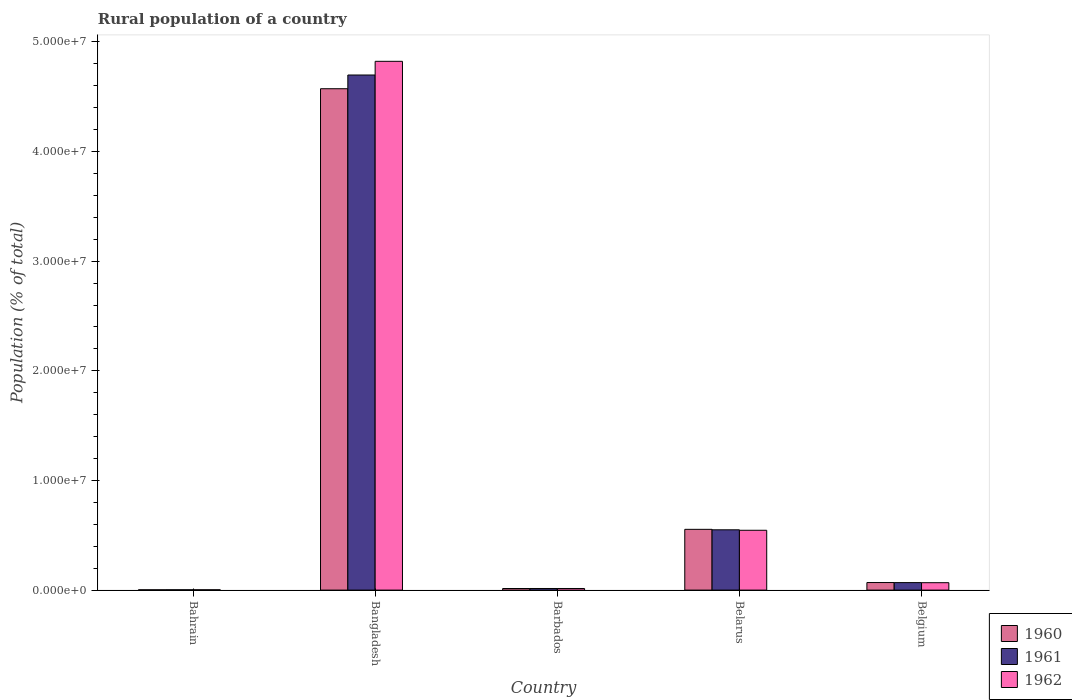How many different coloured bars are there?
Give a very brief answer. 3. How many bars are there on the 5th tick from the left?
Offer a very short reply. 3. How many bars are there on the 4th tick from the right?
Offer a terse response. 3. What is the rural population in 1961 in Belgium?
Offer a terse response. 6.84e+05. Across all countries, what is the maximum rural population in 1960?
Ensure brevity in your answer.  4.57e+07. Across all countries, what is the minimum rural population in 1962?
Keep it short and to the point. 3.05e+04. In which country was the rural population in 1962 maximum?
Your answer should be very brief. Bangladesh. In which country was the rural population in 1962 minimum?
Provide a short and direct response. Bahrain. What is the total rural population in 1962 in the graph?
Your response must be concise. 5.45e+07. What is the difference between the rural population in 1962 in Bahrain and that in Belarus?
Keep it short and to the point. -5.43e+06. What is the difference between the rural population in 1961 in Belarus and the rural population in 1960 in Barbados?
Offer a very short reply. 5.35e+06. What is the average rural population in 1960 per country?
Make the answer very short. 1.04e+07. What is the difference between the rural population of/in 1960 and rural population of/in 1961 in Bangladesh?
Make the answer very short. -1.25e+06. In how many countries, is the rural population in 1960 greater than 4000000 %?
Ensure brevity in your answer.  2. What is the ratio of the rural population in 1960 in Barbados to that in Belarus?
Offer a terse response. 0.03. What is the difference between the highest and the second highest rural population in 1961?
Your response must be concise. 4.63e+07. What is the difference between the highest and the lowest rural population in 1961?
Provide a succinct answer. 4.69e+07. What does the 1st bar from the left in Belarus represents?
Provide a succinct answer. 1960. What does the 3rd bar from the right in Bangladesh represents?
Your response must be concise. 1960. Are all the bars in the graph horizontal?
Keep it short and to the point. No. What is the difference between two consecutive major ticks on the Y-axis?
Offer a very short reply. 1.00e+07. Are the values on the major ticks of Y-axis written in scientific E-notation?
Provide a short and direct response. Yes. Does the graph contain any zero values?
Offer a very short reply. No. Does the graph contain grids?
Offer a terse response. No. What is the title of the graph?
Keep it short and to the point. Rural population of a country. What is the label or title of the Y-axis?
Ensure brevity in your answer.  Population (% of total). What is the Population (% of total) of 1960 in Bahrain?
Offer a terse response. 2.87e+04. What is the Population (% of total) of 1961 in Bahrain?
Your response must be concise. 2.97e+04. What is the Population (% of total) of 1962 in Bahrain?
Offer a very short reply. 3.05e+04. What is the Population (% of total) in 1960 in Bangladesh?
Offer a very short reply. 4.57e+07. What is the Population (% of total) in 1961 in Bangladesh?
Make the answer very short. 4.70e+07. What is the Population (% of total) of 1962 in Bangladesh?
Your answer should be compact. 4.82e+07. What is the Population (% of total) of 1960 in Barbados?
Your answer should be very brief. 1.46e+05. What is the Population (% of total) in 1961 in Barbados?
Provide a short and direct response. 1.46e+05. What is the Population (% of total) in 1962 in Barbados?
Give a very brief answer. 1.47e+05. What is the Population (% of total) in 1960 in Belarus?
Offer a very short reply. 5.54e+06. What is the Population (% of total) in 1961 in Belarus?
Keep it short and to the point. 5.50e+06. What is the Population (% of total) in 1962 in Belarus?
Your answer should be compact. 5.46e+06. What is the Population (% of total) in 1960 in Belgium?
Offer a very short reply. 6.90e+05. What is the Population (% of total) of 1961 in Belgium?
Offer a very short reply. 6.84e+05. What is the Population (% of total) of 1962 in Belgium?
Ensure brevity in your answer.  6.75e+05. Across all countries, what is the maximum Population (% of total) in 1960?
Provide a short and direct response. 4.57e+07. Across all countries, what is the maximum Population (% of total) of 1961?
Provide a succinct answer. 4.70e+07. Across all countries, what is the maximum Population (% of total) of 1962?
Keep it short and to the point. 4.82e+07. Across all countries, what is the minimum Population (% of total) in 1960?
Make the answer very short. 2.87e+04. Across all countries, what is the minimum Population (% of total) of 1961?
Your answer should be compact. 2.97e+04. Across all countries, what is the minimum Population (% of total) in 1962?
Provide a short and direct response. 3.05e+04. What is the total Population (% of total) of 1960 in the graph?
Give a very brief answer. 5.21e+07. What is the total Population (% of total) in 1961 in the graph?
Make the answer very short. 5.33e+07. What is the total Population (% of total) of 1962 in the graph?
Provide a succinct answer. 5.45e+07. What is the difference between the Population (% of total) in 1960 in Bahrain and that in Bangladesh?
Your answer should be compact. -4.57e+07. What is the difference between the Population (% of total) of 1961 in Bahrain and that in Bangladesh?
Ensure brevity in your answer.  -4.69e+07. What is the difference between the Population (% of total) in 1962 in Bahrain and that in Bangladesh?
Keep it short and to the point. -4.82e+07. What is the difference between the Population (% of total) of 1960 in Bahrain and that in Barbados?
Offer a very short reply. -1.17e+05. What is the difference between the Population (% of total) of 1961 in Bahrain and that in Barbados?
Provide a succinct answer. -1.17e+05. What is the difference between the Population (% of total) of 1962 in Bahrain and that in Barbados?
Provide a succinct answer. -1.16e+05. What is the difference between the Population (% of total) of 1960 in Bahrain and that in Belarus?
Your response must be concise. -5.51e+06. What is the difference between the Population (% of total) in 1961 in Bahrain and that in Belarus?
Provide a short and direct response. -5.47e+06. What is the difference between the Population (% of total) in 1962 in Bahrain and that in Belarus?
Your answer should be compact. -5.43e+06. What is the difference between the Population (% of total) of 1960 in Bahrain and that in Belgium?
Offer a terse response. -6.61e+05. What is the difference between the Population (% of total) in 1961 in Bahrain and that in Belgium?
Give a very brief answer. -6.54e+05. What is the difference between the Population (% of total) in 1962 in Bahrain and that in Belgium?
Ensure brevity in your answer.  -6.44e+05. What is the difference between the Population (% of total) of 1960 in Bangladesh and that in Barbados?
Keep it short and to the point. 4.56e+07. What is the difference between the Population (% of total) in 1961 in Bangladesh and that in Barbados?
Your answer should be compact. 4.68e+07. What is the difference between the Population (% of total) of 1962 in Bangladesh and that in Barbados?
Your response must be concise. 4.81e+07. What is the difference between the Population (% of total) of 1960 in Bangladesh and that in Belarus?
Offer a very short reply. 4.02e+07. What is the difference between the Population (% of total) of 1961 in Bangladesh and that in Belarus?
Give a very brief answer. 4.15e+07. What is the difference between the Population (% of total) of 1962 in Bangladesh and that in Belarus?
Make the answer very short. 4.28e+07. What is the difference between the Population (% of total) of 1960 in Bangladesh and that in Belgium?
Keep it short and to the point. 4.50e+07. What is the difference between the Population (% of total) of 1961 in Bangladesh and that in Belgium?
Keep it short and to the point. 4.63e+07. What is the difference between the Population (% of total) in 1962 in Bangladesh and that in Belgium?
Provide a succinct answer. 4.75e+07. What is the difference between the Population (% of total) of 1960 in Barbados and that in Belarus?
Give a very brief answer. -5.40e+06. What is the difference between the Population (% of total) of 1961 in Barbados and that in Belarus?
Your answer should be compact. -5.35e+06. What is the difference between the Population (% of total) in 1962 in Barbados and that in Belarus?
Your answer should be very brief. -5.31e+06. What is the difference between the Population (% of total) of 1960 in Barbados and that in Belgium?
Give a very brief answer. -5.44e+05. What is the difference between the Population (% of total) in 1961 in Barbados and that in Belgium?
Provide a succinct answer. -5.38e+05. What is the difference between the Population (% of total) of 1962 in Barbados and that in Belgium?
Provide a succinct answer. -5.28e+05. What is the difference between the Population (% of total) of 1960 in Belarus and that in Belgium?
Make the answer very short. 4.85e+06. What is the difference between the Population (% of total) of 1961 in Belarus and that in Belgium?
Keep it short and to the point. 4.81e+06. What is the difference between the Population (% of total) of 1962 in Belarus and that in Belgium?
Provide a succinct answer. 4.78e+06. What is the difference between the Population (% of total) in 1960 in Bahrain and the Population (% of total) in 1961 in Bangladesh?
Your response must be concise. -4.69e+07. What is the difference between the Population (% of total) in 1960 in Bahrain and the Population (% of total) in 1962 in Bangladesh?
Provide a succinct answer. -4.82e+07. What is the difference between the Population (% of total) of 1961 in Bahrain and the Population (% of total) of 1962 in Bangladesh?
Make the answer very short. -4.82e+07. What is the difference between the Population (% of total) of 1960 in Bahrain and the Population (% of total) of 1961 in Barbados?
Provide a succinct answer. -1.18e+05. What is the difference between the Population (% of total) of 1960 in Bahrain and the Population (% of total) of 1962 in Barbados?
Ensure brevity in your answer.  -1.18e+05. What is the difference between the Population (% of total) in 1961 in Bahrain and the Population (% of total) in 1962 in Barbados?
Give a very brief answer. -1.17e+05. What is the difference between the Population (% of total) of 1960 in Bahrain and the Population (% of total) of 1961 in Belarus?
Provide a short and direct response. -5.47e+06. What is the difference between the Population (% of total) of 1960 in Bahrain and the Population (% of total) of 1962 in Belarus?
Provide a succinct answer. -5.43e+06. What is the difference between the Population (% of total) of 1961 in Bahrain and the Population (% of total) of 1962 in Belarus?
Ensure brevity in your answer.  -5.43e+06. What is the difference between the Population (% of total) of 1960 in Bahrain and the Population (% of total) of 1961 in Belgium?
Provide a short and direct response. -6.55e+05. What is the difference between the Population (% of total) of 1960 in Bahrain and the Population (% of total) of 1962 in Belgium?
Offer a terse response. -6.46e+05. What is the difference between the Population (% of total) of 1961 in Bahrain and the Population (% of total) of 1962 in Belgium?
Your answer should be very brief. -6.45e+05. What is the difference between the Population (% of total) of 1960 in Bangladesh and the Population (% of total) of 1961 in Barbados?
Keep it short and to the point. 4.56e+07. What is the difference between the Population (% of total) of 1960 in Bangladesh and the Population (% of total) of 1962 in Barbados?
Keep it short and to the point. 4.56e+07. What is the difference between the Population (% of total) in 1961 in Bangladesh and the Population (% of total) in 1962 in Barbados?
Offer a terse response. 4.68e+07. What is the difference between the Population (% of total) in 1960 in Bangladesh and the Population (% of total) in 1961 in Belarus?
Make the answer very short. 4.02e+07. What is the difference between the Population (% of total) of 1960 in Bangladesh and the Population (% of total) of 1962 in Belarus?
Offer a terse response. 4.03e+07. What is the difference between the Population (% of total) in 1961 in Bangladesh and the Population (% of total) in 1962 in Belarus?
Ensure brevity in your answer.  4.15e+07. What is the difference between the Population (% of total) in 1960 in Bangladesh and the Population (% of total) in 1961 in Belgium?
Keep it short and to the point. 4.50e+07. What is the difference between the Population (% of total) in 1960 in Bangladesh and the Population (% of total) in 1962 in Belgium?
Your answer should be compact. 4.51e+07. What is the difference between the Population (% of total) in 1961 in Bangladesh and the Population (% of total) in 1962 in Belgium?
Offer a very short reply. 4.63e+07. What is the difference between the Population (% of total) of 1960 in Barbados and the Population (% of total) of 1961 in Belarus?
Make the answer very short. -5.35e+06. What is the difference between the Population (% of total) of 1960 in Barbados and the Population (% of total) of 1962 in Belarus?
Your response must be concise. -5.31e+06. What is the difference between the Population (% of total) in 1961 in Barbados and the Population (% of total) in 1962 in Belarus?
Ensure brevity in your answer.  -5.31e+06. What is the difference between the Population (% of total) in 1960 in Barbados and the Population (% of total) in 1961 in Belgium?
Offer a terse response. -5.38e+05. What is the difference between the Population (% of total) in 1960 in Barbados and the Population (% of total) in 1962 in Belgium?
Ensure brevity in your answer.  -5.29e+05. What is the difference between the Population (% of total) in 1961 in Barbados and the Population (% of total) in 1962 in Belgium?
Your response must be concise. -5.29e+05. What is the difference between the Population (% of total) of 1960 in Belarus and the Population (% of total) of 1961 in Belgium?
Provide a succinct answer. 4.86e+06. What is the difference between the Population (% of total) of 1960 in Belarus and the Population (% of total) of 1962 in Belgium?
Provide a succinct answer. 4.87e+06. What is the difference between the Population (% of total) in 1961 in Belarus and the Population (% of total) in 1962 in Belgium?
Offer a very short reply. 4.82e+06. What is the average Population (% of total) in 1960 per country?
Provide a short and direct response. 1.04e+07. What is the average Population (% of total) of 1961 per country?
Make the answer very short. 1.07e+07. What is the average Population (% of total) of 1962 per country?
Your answer should be very brief. 1.09e+07. What is the difference between the Population (% of total) in 1960 and Population (% of total) in 1961 in Bahrain?
Provide a succinct answer. -930. What is the difference between the Population (% of total) of 1960 and Population (% of total) of 1962 in Bahrain?
Provide a succinct answer. -1815. What is the difference between the Population (% of total) in 1961 and Population (% of total) in 1962 in Bahrain?
Offer a terse response. -885. What is the difference between the Population (% of total) in 1960 and Population (% of total) in 1961 in Bangladesh?
Offer a terse response. -1.25e+06. What is the difference between the Population (% of total) of 1960 and Population (% of total) of 1962 in Bangladesh?
Make the answer very short. -2.50e+06. What is the difference between the Population (% of total) of 1961 and Population (% of total) of 1962 in Bangladesh?
Keep it short and to the point. -1.25e+06. What is the difference between the Population (% of total) of 1960 and Population (% of total) of 1961 in Barbados?
Give a very brief answer. -301. What is the difference between the Population (% of total) in 1960 and Population (% of total) in 1962 in Barbados?
Your answer should be compact. -706. What is the difference between the Population (% of total) in 1961 and Population (% of total) in 1962 in Barbados?
Provide a succinct answer. -405. What is the difference between the Population (% of total) of 1960 and Population (% of total) of 1961 in Belarus?
Provide a succinct answer. 4.32e+04. What is the difference between the Population (% of total) in 1960 and Population (% of total) in 1962 in Belarus?
Your answer should be very brief. 8.49e+04. What is the difference between the Population (% of total) of 1961 and Population (% of total) of 1962 in Belarus?
Give a very brief answer. 4.16e+04. What is the difference between the Population (% of total) of 1960 and Population (% of total) of 1961 in Belgium?
Keep it short and to the point. 6336. What is the difference between the Population (% of total) in 1960 and Population (% of total) in 1962 in Belgium?
Give a very brief answer. 1.51e+04. What is the difference between the Population (% of total) of 1961 and Population (% of total) of 1962 in Belgium?
Keep it short and to the point. 8798. What is the ratio of the Population (% of total) in 1960 in Bahrain to that in Bangladesh?
Provide a short and direct response. 0. What is the ratio of the Population (% of total) of 1961 in Bahrain to that in Bangladesh?
Your answer should be very brief. 0. What is the ratio of the Population (% of total) of 1962 in Bahrain to that in Bangladesh?
Make the answer very short. 0. What is the ratio of the Population (% of total) in 1960 in Bahrain to that in Barbados?
Make the answer very short. 0.2. What is the ratio of the Population (% of total) in 1961 in Bahrain to that in Barbados?
Your answer should be compact. 0.2. What is the ratio of the Population (% of total) in 1962 in Bahrain to that in Barbados?
Provide a short and direct response. 0.21. What is the ratio of the Population (% of total) of 1960 in Bahrain to that in Belarus?
Ensure brevity in your answer.  0.01. What is the ratio of the Population (% of total) in 1961 in Bahrain to that in Belarus?
Give a very brief answer. 0.01. What is the ratio of the Population (% of total) in 1962 in Bahrain to that in Belarus?
Provide a succinct answer. 0.01. What is the ratio of the Population (% of total) in 1960 in Bahrain to that in Belgium?
Keep it short and to the point. 0.04. What is the ratio of the Population (% of total) of 1961 in Bahrain to that in Belgium?
Keep it short and to the point. 0.04. What is the ratio of the Population (% of total) of 1962 in Bahrain to that in Belgium?
Provide a short and direct response. 0.05. What is the ratio of the Population (% of total) of 1960 in Bangladesh to that in Barbados?
Give a very brief answer. 313.18. What is the ratio of the Population (% of total) in 1961 in Bangladesh to that in Barbados?
Keep it short and to the point. 321.09. What is the ratio of the Population (% of total) of 1962 in Bangladesh to that in Barbados?
Provide a succinct answer. 328.71. What is the ratio of the Population (% of total) of 1960 in Bangladesh to that in Belarus?
Your answer should be very brief. 8.25. What is the ratio of the Population (% of total) of 1961 in Bangladesh to that in Belarus?
Ensure brevity in your answer.  8.54. What is the ratio of the Population (% of total) of 1962 in Bangladesh to that in Belarus?
Your response must be concise. 8.84. What is the ratio of the Population (% of total) in 1960 in Bangladesh to that in Belgium?
Your answer should be compact. 66.25. What is the ratio of the Population (% of total) in 1961 in Bangladesh to that in Belgium?
Offer a terse response. 68.69. What is the ratio of the Population (% of total) of 1962 in Bangladesh to that in Belgium?
Your response must be concise. 71.44. What is the ratio of the Population (% of total) in 1960 in Barbados to that in Belarus?
Your response must be concise. 0.03. What is the ratio of the Population (% of total) in 1961 in Barbados to that in Belarus?
Provide a short and direct response. 0.03. What is the ratio of the Population (% of total) in 1962 in Barbados to that in Belarus?
Your answer should be compact. 0.03. What is the ratio of the Population (% of total) in 1960 in Barbados to that in Belgium?
Give a very brief answer. 0.21. What is the ratio of the Population (% of total) of 1961 in Barbados to that in Belgium?
Your answer should be very brief. 0.21. What is the ratio of the Population (% of total) in 1962 in Barbados to that in Belgium?
Make the answer very short. 0.22. What is the ratio of the Population (% of total) in 1960 in Belarus to that in Belgium?
Give a very brief answer. 8.03. What is the ratio of the Population (% of total) in 1961 in Belarus to that in Belgium?
Provide a short and direct response. 8.04. What is the ratio of the Population (% of total) of 1962 in Belarus to that in Belgium?
Ensure brevity in your answer.  8.08. What is the difference between the highest and the second highest Population (% of total) in 1960?
Make the answer very short. 4.02e+07. What is the difference between the highest and the second highest Population (% of total) of 1961?
Provide a succinct answer. 4.15e+07. What is the difference between the highest and the second highest Population (% of total) of 1962?
Your answer should be compact. 4.28e+07. What is the difference between the highest and the lowest Population (% of total) of 1960?
Make the answer very short. 4.57e+07. What is the difference between the highest and the lowest Population (% of total) of 1961?
Your response must be concise. 4.69e+07. What is the difference between the highest and the lowest Population (% of total) in 1962?
Offer a terse response. 4.82e+07. 